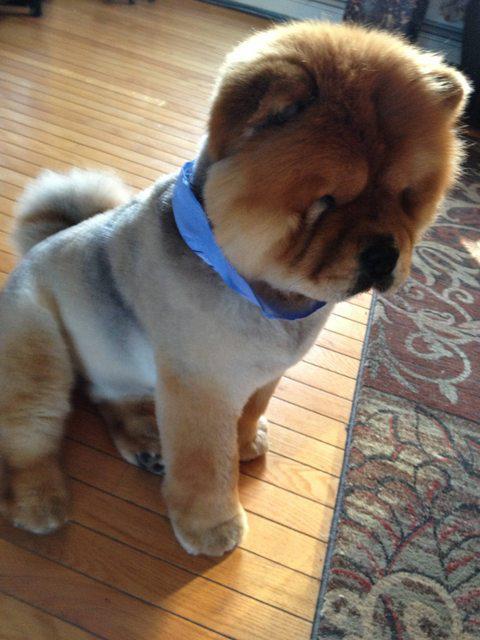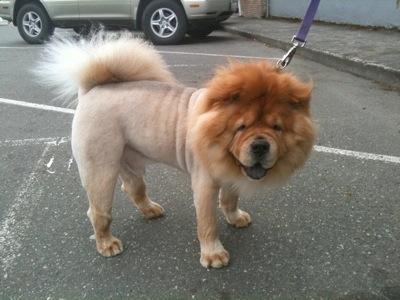The first image is the image on the left, the second image is the image on the right. Examine the images to the left and right. Is the description "The dog in the right image is attached to a purple leash." accurate? Answer yes or no. Yes. The first image is the image on the left, the second image is the image on the right. Given the left and right images, does the statement "Right image shows a standing chow dog, and left image shows a different breed of dog standing." hold true? Answer yes or no. No. 